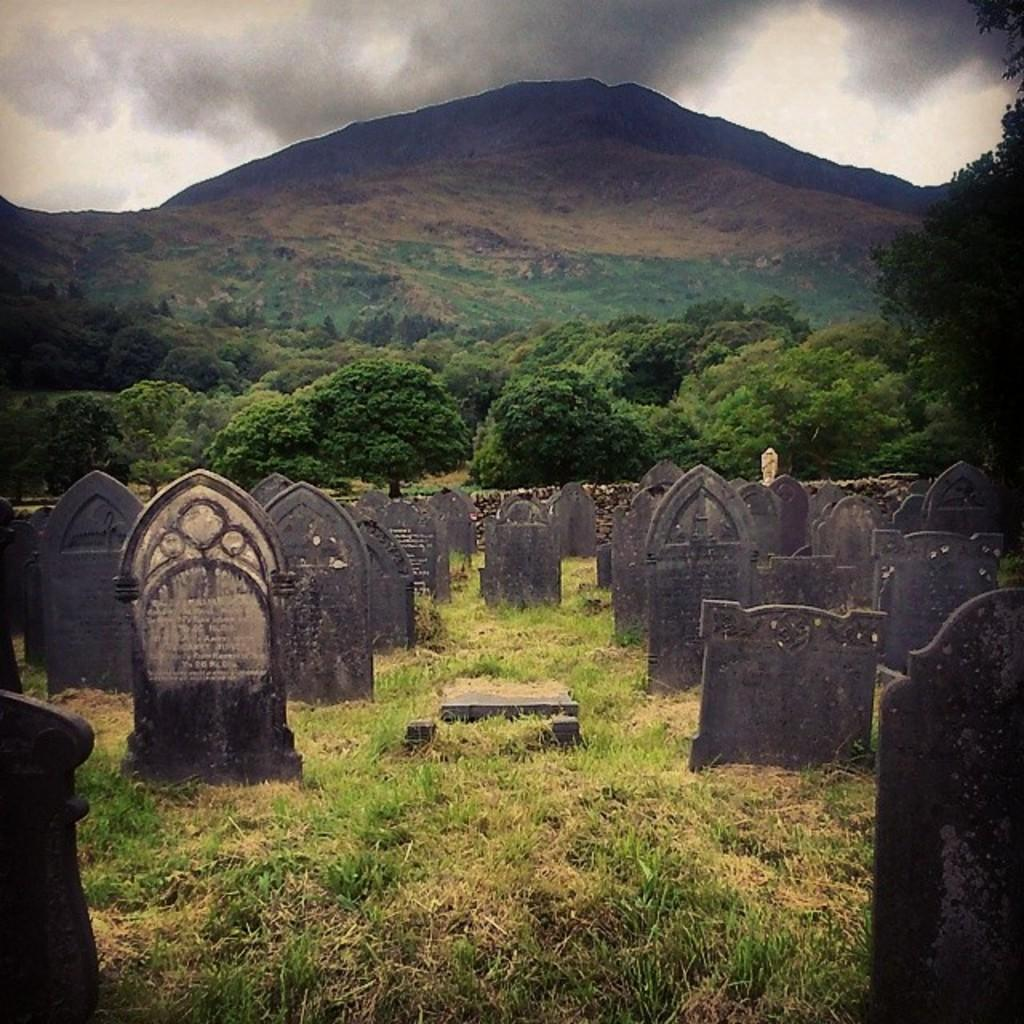What type of pattern can be observed in the image? There are symmetries in the image. What can be seen in the background of the image? There are plants and mountains visible in the background of the image. What is the color of the plants in the image? The plants in the image are green. How would you describe the color of the sky in the image? The sky is white and gray in color. What month is it in the image? The image does not provide any information about the month or time of year. Who is the manager of the plants in the image? There is no indication of a manager or any human involvement in the image; it only shows plants, mountains, and the sky. 